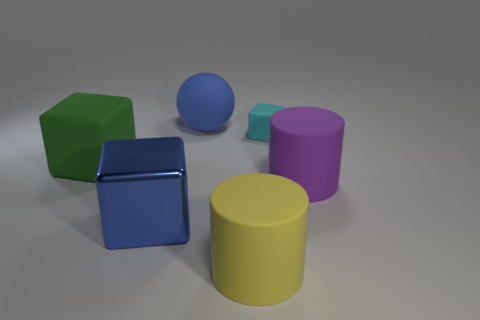Can you describe the arrangement of the objects by their colors? Certainly! In the image, from left to right, there's a green cube, a matte finish blue cube, a purplish-pink cylinder, and a large yellow cylinder. Behind these objects, almost in line with the green cube, is a smaller, shiny metallic cube, slightly to its right. And finally, behind the blue cube, there's a blue sphere. 